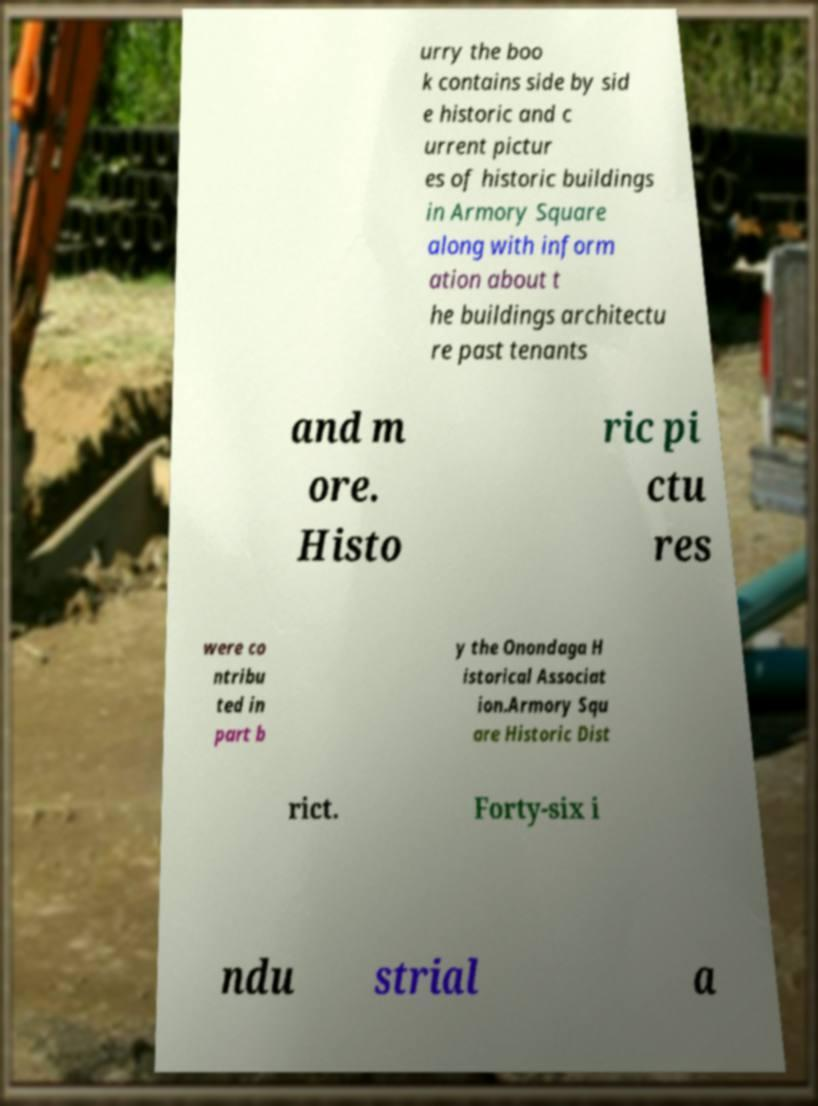There's text embedded in this image that I need extracted. Can you transcribe it verbatim? urry the boo k contains side by sid e historic and c urrent pictur es of historic buildings in Armory Square along with inform ation about t he buildings architectu re past tenants and m ore. Histo ric pi ctu res were co ntribu ted in part b y the Onondaga H istorical Associat ion.Armory Squ are Historic Dist rict. Forty-six i ndu strial a 